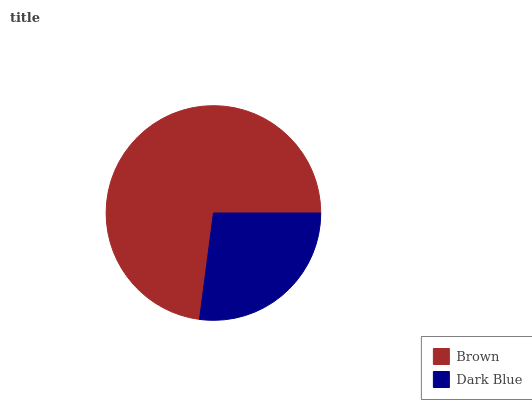Is Dark Blue the minimum?
Answer yes or no. Yes. Is Brown the maximum?
Answer yes or no. Yes. Is Dark Blue the maximum?
Answer yes or no. No. Is Brown greater than Dark Blue?
Answer yes or no. Yes. Is Dark Blue less than Brown?
Answer yes or no. Yes. Is Dark Blue greater than Brown?
Answer yes or no. No. Is Brown less than Dark Blue?
Answer yes or no. No. Is Brown the high median?
Answer yes or no. Yes. Is Dark Blue the low median?
Answer yes or no. Yes. Is Dark Blue the high median?
Answer yes or no. No. Is Brown the low median?
Answer yes or no. No. 